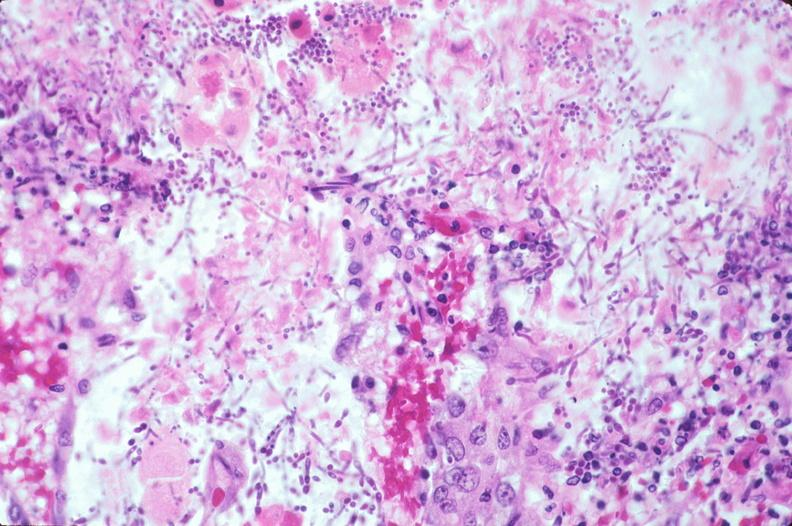does this image show duodenum, necrotizing enteritis with pseudomembrane, candida?
Answer the question using a single word or phrase. Yes 